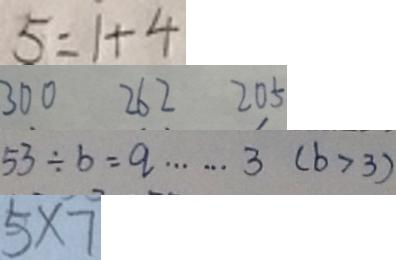Convert formula to latex. <formula><loc_0><loc_0><loc_500><loc_500>5 = 1 + 4 
 3 0 0 2 6 2 2 0 5 
 5 3 \div b = q \cdots 3 ( b > 3 ) 
 5 \times 7</formula> 